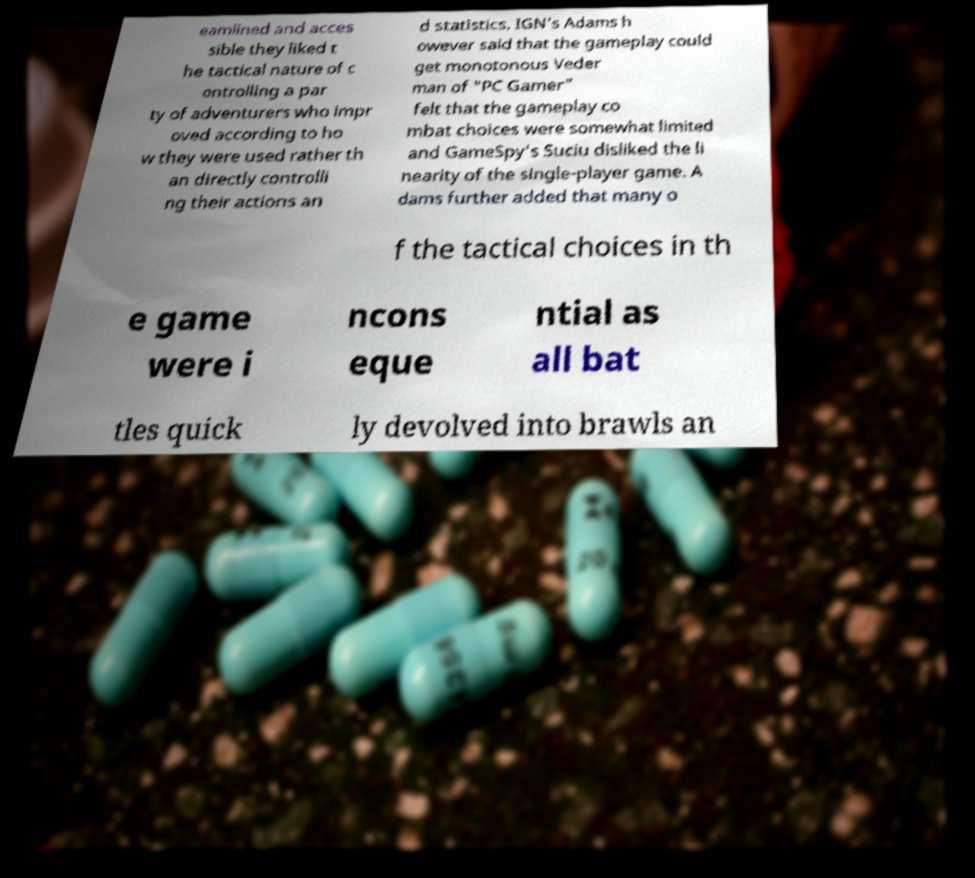I need the written content from this picture converted into text. Can you do that? eamlined and acces sible they liked t he tactical nature of c ontrolling a par ty of adventurers who impr oved according to ho w they were used rather th an directly controlli ng their actions an d statistics. IGN's Adams h owever said that the gameplay could get monotonous Veder man of "PC Gamer" felt that the gameplay co mbat choices were somewhat limited and GameSpy's Suciu disliked the li nearity of the single-player game. A dams further added that many o f the tactical choices in th e game were i ncons eque ntial as all bat tles quick ly devolved into brawls an 